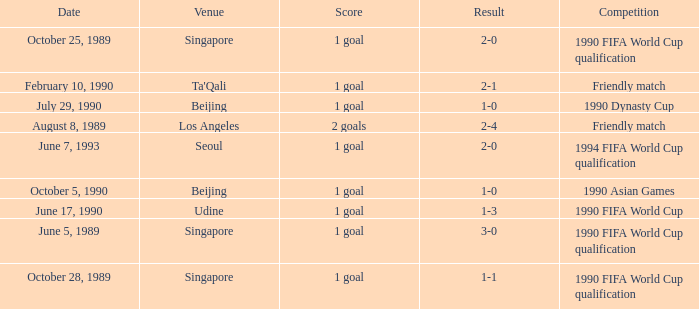What was the venue where the result was 2-1? Ta'Qali. 